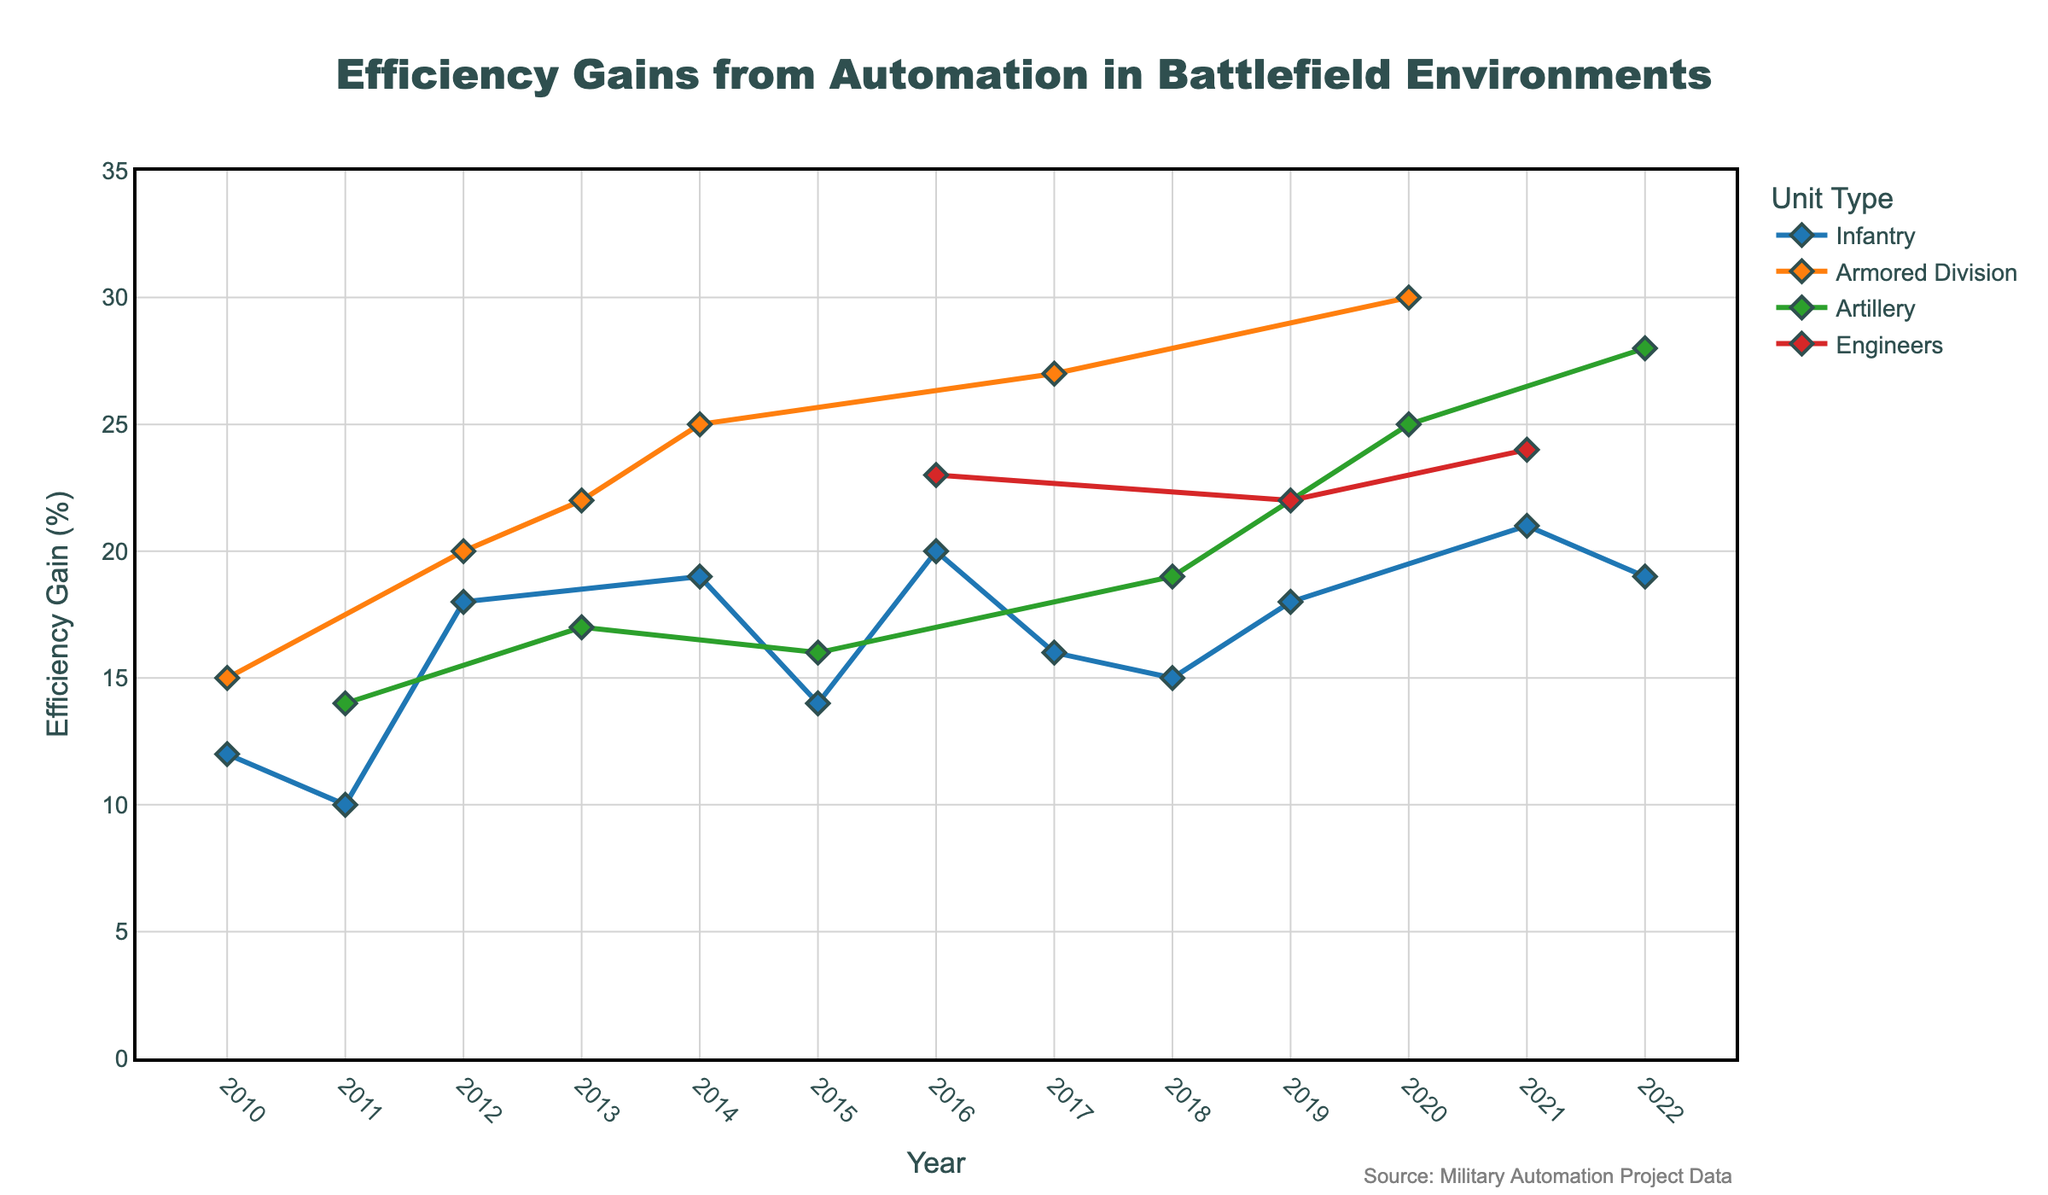What is the title of the plot? The title is the text at the top of the plot that provides an overview of what the plot represents. It's essential for understanding the context of the data.
Answer: Efficiency Gains from Automation in Battlefield Environments Which unit type shows the highest efficiency gain in 2020? To find the highest efficiency gain in 2020, locate the data points for each unit type in that year and compare their values. The unit type with the largest value is the highest.
Answer: Armored Division What is the average efficiency gain for Infantry units over the plotted years? First, identify all the data points for Infantry units and note their values. Then, sum these values and divide by the number of data points to get the average. The values are 12, 10, 18, 19, 14, 20, 16, 15, 18, 21, and 19.
Answer: 16.36 Between which two years did the Armored Division show the highest increase in efficiency gain? Identify and compare the efficiencies of the Armored Division across all the years. Find the highest increase by calculating the difference between yearly values and note the years.
Answer: 2019 to 2020 Which operation showed the lowest efficiency gain for Artillery units? Locate the efficiency gains for all Artillery units for each operation, and find the smallest value.
Answer: 2011, Operation Freedom Eagle How many unique unit types are represented in the plot? Count the different unit types listed in the legend or on the x-axis to determine the number of unique types.
Answer: 4 Comparing 2016 and 2018, which year had a higher efficiency gain for Engineers? Look at the efficiency gain values for Engineers in both 2016 and 2018 and compare them directly.
Answer: 2016 Which year had the most varied efficiency gains among all unit types? Determine the year where the difference between the highest and lowest efficiency gains among all unit types is the largest. Compare the range in efficiency gains for each year to find this.
Answer: 2020 What is the efficiency gain trend for Infantry units from 2010 to 2022? Plot the efficiency gains for Infantry units over the years and evaluate whether the trend is increasing, decreasing, or fluctuating.
Answer: Fluctuating but generally increasing 